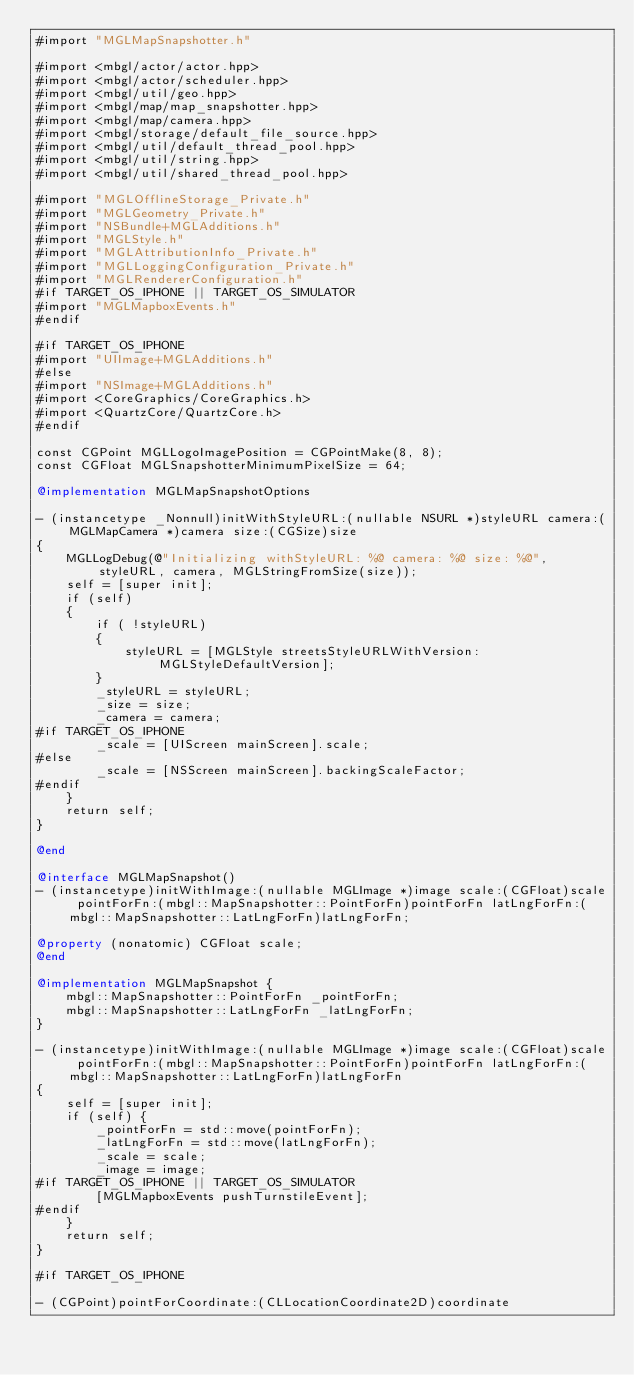Convert code to text. <code><loc_0><loc_0><loc_500><loc_500><_ObjectiveC_>#import "MGLMapSnapshotter.h"

#import <mbgl/actor/actor.hpp>
#import <mbgl/actor/scheduler.hpp>
#import <mbgl/util/geo.hpp>
#import <mbgl/map/map_snapshotter.hpp>
#import <mbgl/map/camera.hpp>
#import <mbgl/storage/default_file_source.hpp>
#import <mbgl/util/default_thread_pool.hpp>
#import <mbgl/util/string.hpp>
#import <mbgl/util/shared_thread_pool.hpp>

#import "MGLOfflineStorage_Private.h"
#import "MGLGeometry_Private.h"
#import "NSBundle+MGLAdditions.h"
#import "MGLStyle.h"
#import "MGLAttributionInfo_Private.h"
#import "MGLLoggingConfiguration_Private.h"
#import "MGLRendererConfiguration.h"
#if TARGET_OS_IPHONE || TARGET_OS_SIMULATOR
#import "MGLMapboxEvents.h"
#endif

#if TARGET_OS_IPHONE
#import "UIImage+MGLAdditions.h"
#else
#import "NSImage+MGLAdditions.h"
#import <CoreGraphics/CoreGraphics.h>
#import <QuartzCore/QuartzCore.h>
#endif

const CGPoint MGLLogoImagePosition = CGPointMake(8, 8);
const CGFloat MGLSnapshotterMinimumPixelSize = 64;

@implementation MGLMapSnapshotOptions

- (instancetype _Nonnull)initWithStyleURL:(nullable NSURL *)styleURL camera:(MGLMapCamera *)camera size:(CGSize)size
{
    MGLLogDebug(@"Initializing withStyleURL: %@ camera: %@ size: %@", styleURL, camera, MGLStringFromSize(size));
    self = [super init];
    if (self)
    {
        if ( !styleURL)
        {
            styleURL = [MGLStyle streetsStyleURLWithVersion:MGLStyleDefaultVersion];
        }
        _styleURL = styleURL;
        _size = size;
        _camera = camera;
#if TARGET_OS_IPHONE
        _scale = [UIScreen mainScreen].scale;
#else
        _scale = [NSScreen mainScreen].backingScaleFactor;
#endif
    }
    return self;
}

@end

@interface MGLMapSnapshot()
- (instancetype)initWithImage:(nullable MGLImage *)image scale:(CGFloat)scale pointForFn:(mbgl::MapSnapshotter::PointForFn)pointForFn latLngForFn:(mbgl::MapSnapshotter::LatLngForFn)latLngForFn;

@property (nonatomic) CGFloat scale;
@end

@implementation MGLMapSnapshot {
    mbgl::MapSnapshotter::PointForFn _pointForFn;
    mbgl::MapSnapshotter::LatLngForFn _latLngForFn;
}

- (instancetype)initWithImage:(nullable MGLImage *)image scale:(CGFloat)scale pointForFn:(mbgl::MapSnapshotter::PointForFn)pointForFn latLngForFn:(mbgl::MapSnapshotter::LatLngForFn)latLngForFn
{
    self = [super init];
    if (self) {
        _pointForFn = std::move(pointForFn);
        _latLngForFn = std::move(latLngForFn);
        _scale = scale;
        _image = image;
#if TARGET_OS_IPHONE || TARGET_OS_SIMULATOR
        [MGLMapboxEvents pushTurnstileEvent];
#endif
    }
    return self;
}

#if TARGET_OS_IPHONE

- (CGPoint)pointForCoordinate:(CLLocationCoordinate2D)coordinate</code> 